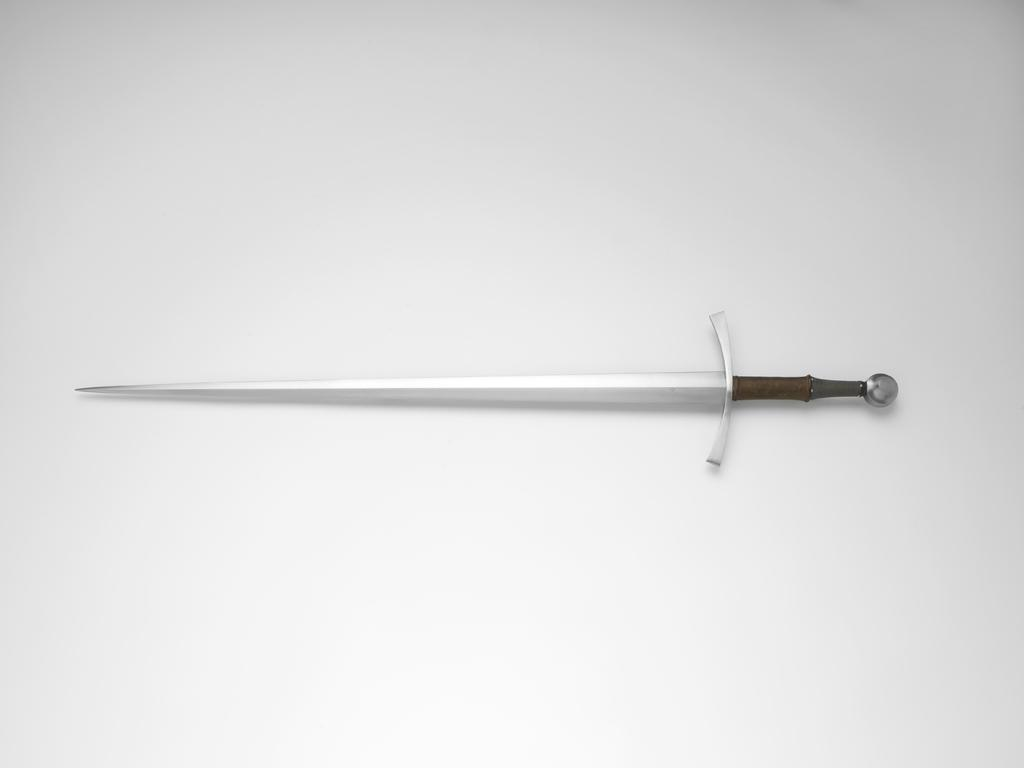What object is the main focus of the image? There is a sword in the image. What color is the background of the image? The background of the image is white. Are there any police officers or crooks visible in the image? There is no mention of police officers or crooks in the provided facts, so we cannot determine their presence in the image. 